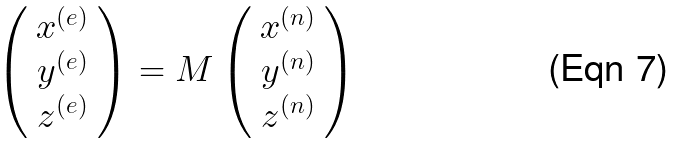<formula> <loc_0><loc_0><loc_500><loc_500>\left ( \begin{array} { c } x ^ { ( e ) } \\ y ^ { ( e ) } \\ z ^ { ( e ) } \end{array} \right ) = M \left ( \begin{array} { c } x ^ { ( n ) } \\ y ^ { ( n ) } \\ z ^ { ( n ) } \end{array} \right )</formula> 